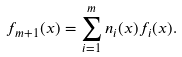<formula> <loc_0><loc_0><loc_500><loc_500>f _ { m + 1 } ( x ) = \sum ^ { m } _ { i = 1 } n _ { i } ( x ) f _ { i } ( x ) .</formula> 